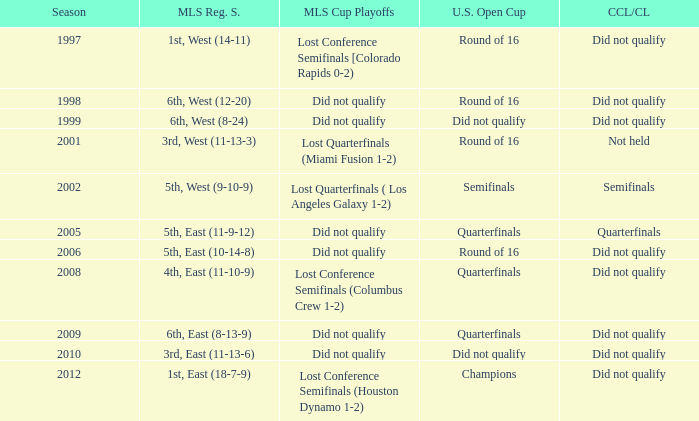How did the team place when they did not qualify for the Concaf Champions Cup but made it to Round of 16 in the U.S. Open Cup? Lost Conference Semifinals [Colorado Rapids 0-2), Did not qualify, Did not qualify. 